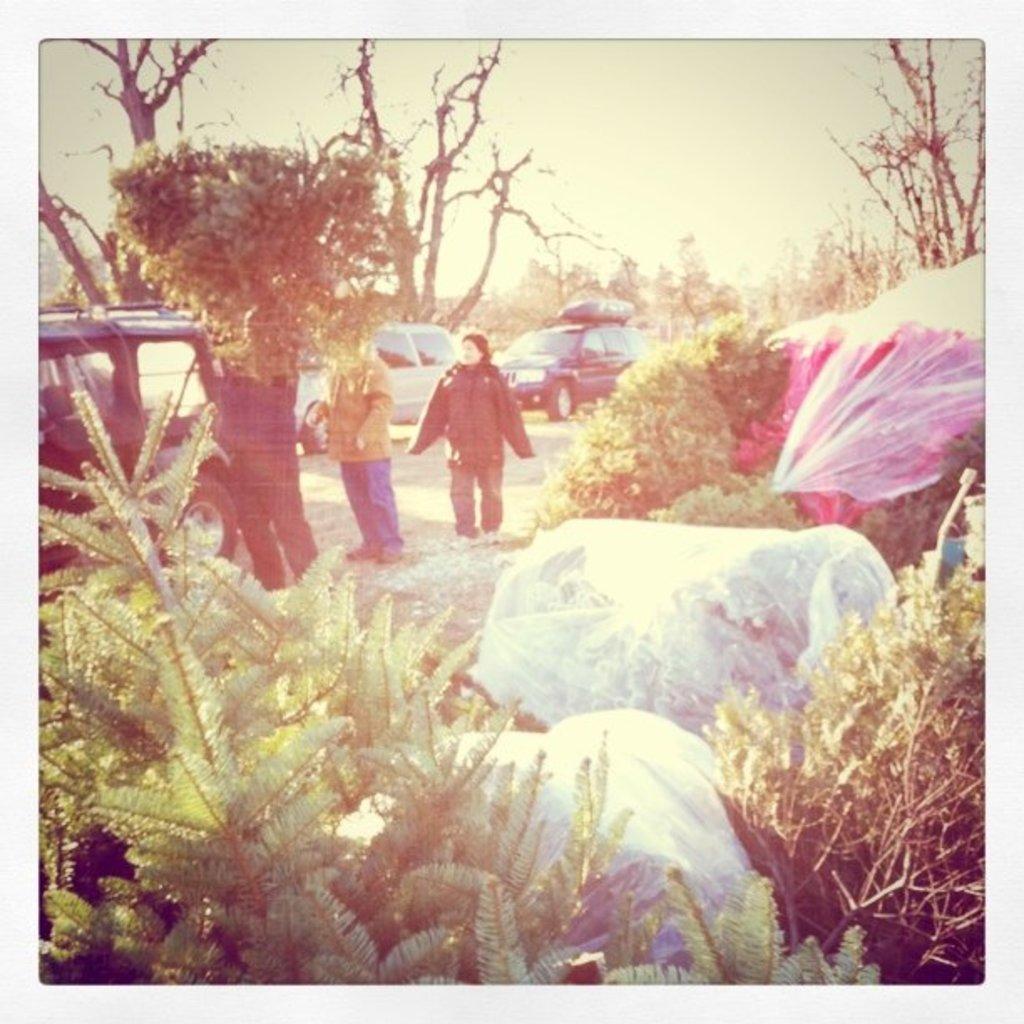In one or two sentences, can you explain what this image depicts? This is an edited picture. I can see vehicles on the road, there are three persons standing, there are plants, bags, there are trees, and in the background there is the sky. 